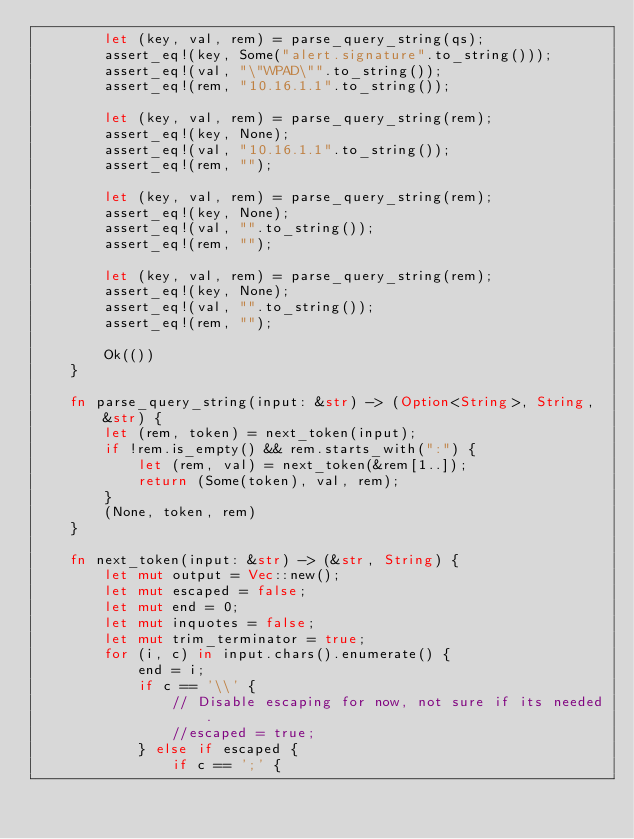<code> <loc_0><loc_0><loc_500><loc_500><_Rust_>        let (key, val, rem) = parse_query_string(qs);
        assert_eq!(key, Some("alert.signature".to_string()));
        assert_eq!(val, "\"WPAD\"".to_string());
        assert_eq!(rem, "10.16.1.1".to_string());

        let (key, val, rem) = parse_query_string(rem);
        assert_eq!(key, None);
        assert_eq!(val, "10.16.1.1".to_string());
        assert_eq!(rem, "");

        let (key, val, rem) = parse_query_string(rem);
        assert_eq!(key, None);
        assert_eq!(val, "".to_string());
        assert_eq!(rem, "");

        let (key, val, rem) = parse_query_string(rem);
        assert_eq!(key, None);
        assert_eq!(val, "".to_string());
        assert_eq!(rem, "");

        Ok(())
    }

    fn parse_query_string(input: &str) -> (Option<String>, String, &str) {
        let (rem, token) = next_token(input);
        if !rem.is_empty() && rem.starts_with(":") {
            let (rem, val) = next_token(&rem[1..]);
            return (Some(token), val, rem);
        }
        (None, token, rem)
    }

    fn next_token(input: &str) -> (&str, String) {
        let mut output = Vec::new();
        let mut escaped = false;
        let mut end = 0;
        let mut inquotes = false;
        let mut trim_terminator = true;
        for (i, c) in input.chars().enumerate() {
            end = i;
            if c == '\\' {
                // Disable escaping for now, not sure if its needed.
                //escaped = true;
            } else if escaped {
                if c == ';' {</code> 